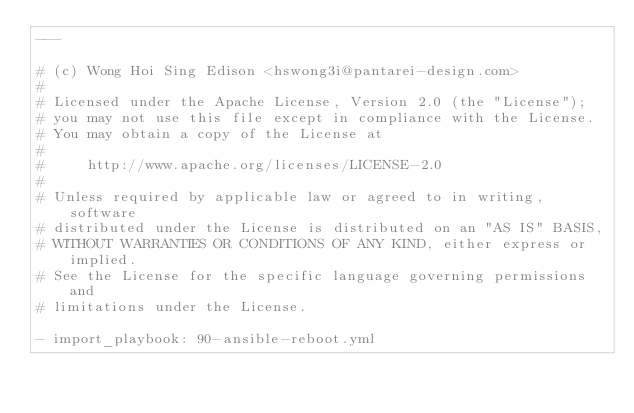Convert code to text. <code><loc_0><loc_0><loc_500><loc_500><_YAML_>---

# (c) Wong Hoi Sing Edison <hswong3i@pantarei-design.com>
#
# Licensed under the Apache License, Version 2.0 (the "License");
# you may not use this file except in compliance with the License.
# You may obtain a copy of the License at
#
#     http://www.apache.org/licenses/LICENSE-2.0
#
# Unless required by applicable law or agreed to in writing, software
# distributed under the License is distributed on an "AS IS" BASIS,
# WITHOUT WARRANTIES OR CONDITIONS OF ANY KIND, either express or implied.
# See the License for the specific language governing permissions and
# limitations under the License.

- import_playbook: 90-ansible-reboot.yml
</code> 